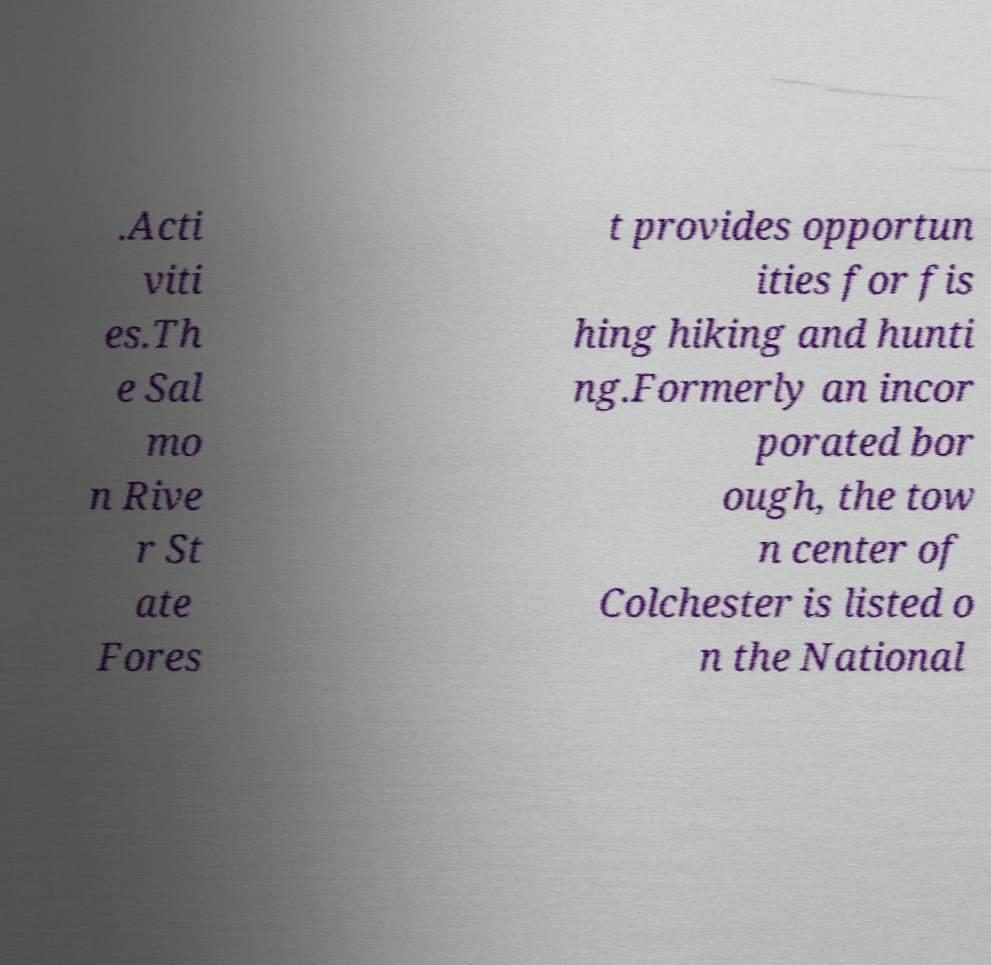Could you extract and type out the text from this image? .Acti viti es.Th e Sal mo n Rive r St ate Fores t provides opportun ities for fis hing hiking and hunti ng.Formerly an incor porated bor ough, the tow n center of Colchester is listed o n the National 